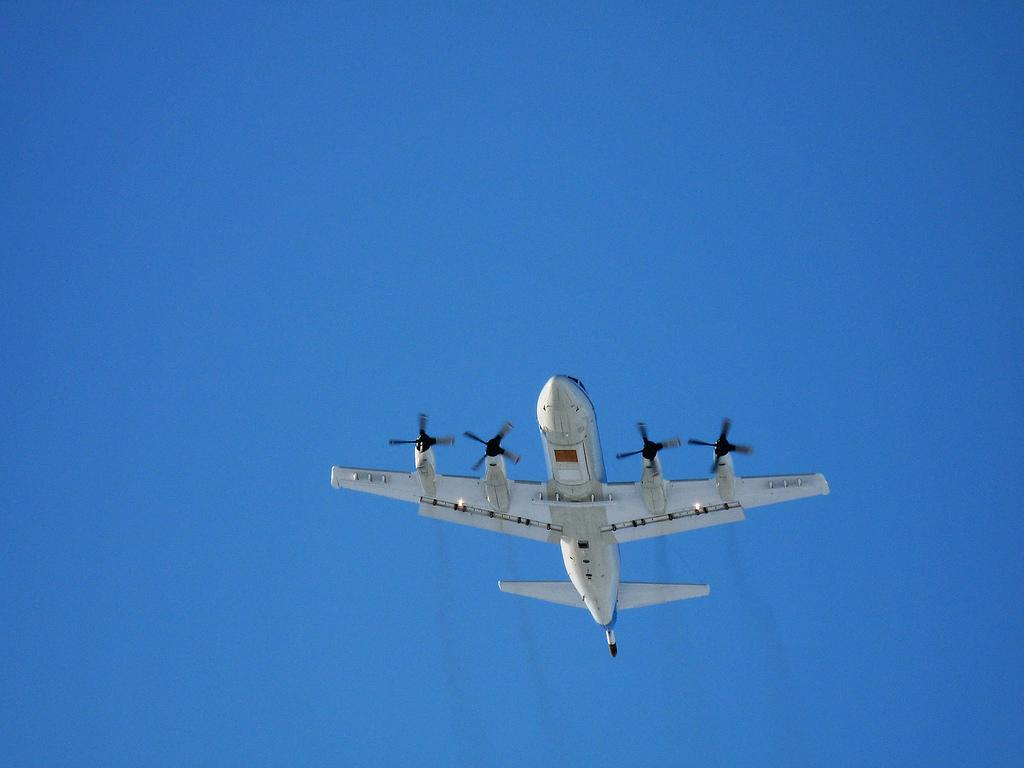What is the main subject of the image? The main subject of the image is an airplane. What is the airplane doing in the image? The airplane is flying in the sky. What type of mitten is the airplane wearing in the image? There is no mitten present in the image, as airplanes do not wear mittens. 